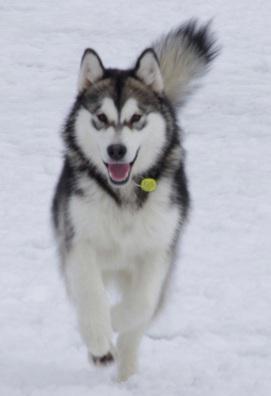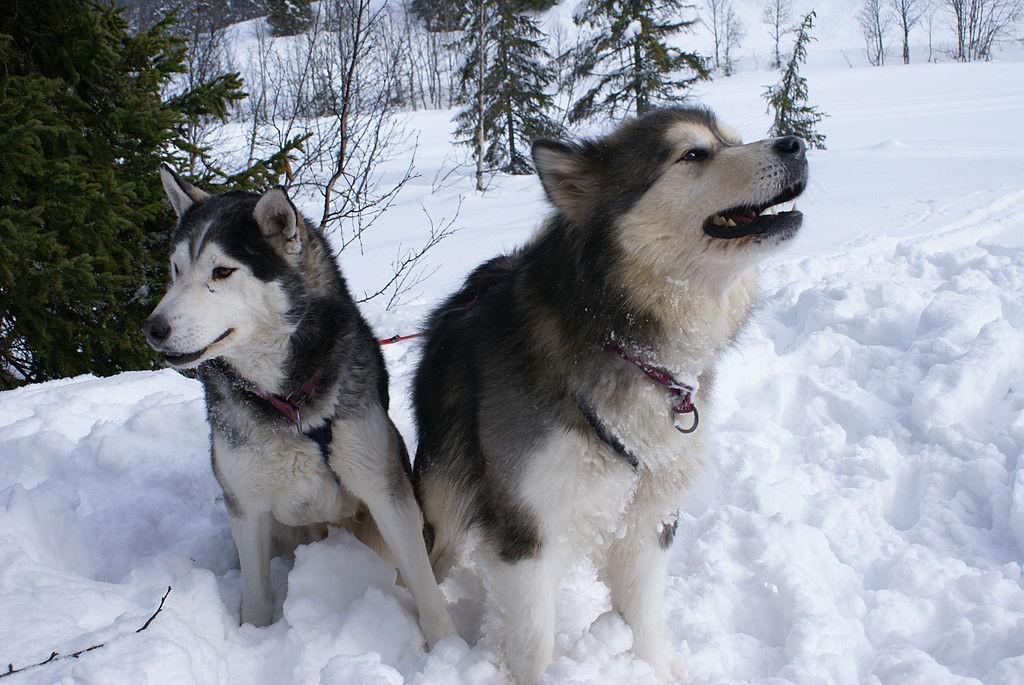The first image is the image on the left, the second image is the image on the right. Analyze the images presented: Is the assertion "There are three dogs." valid? Answer yes or no. Yes. The first image is the image on the left, the second image is the image on the right. For the images shown, is this caption "The left and right image contains the same number of dogs." true? Answer yes or no. No. 